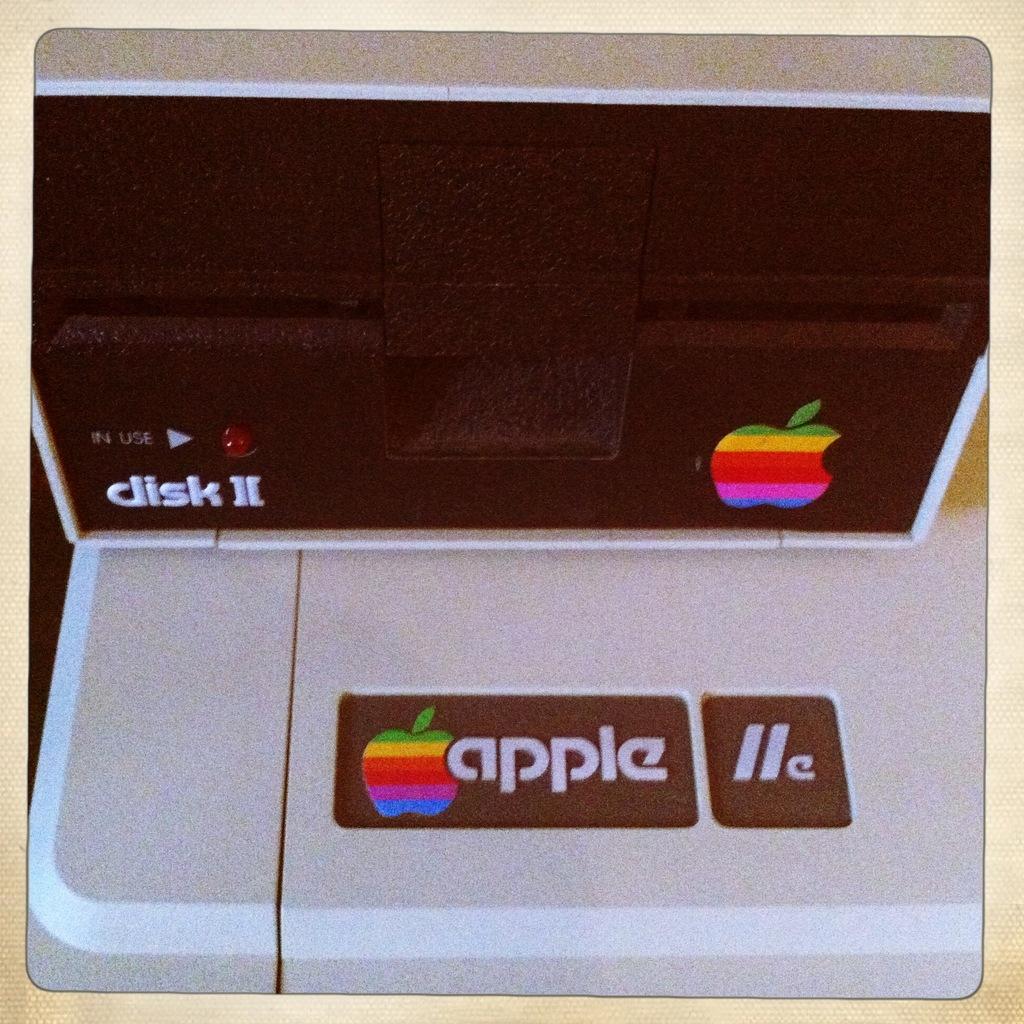What is the brand name of this computer?
Your response must be concise. Apple. What would go into the slot?
Ensure brevity in your answer.  Disk. 